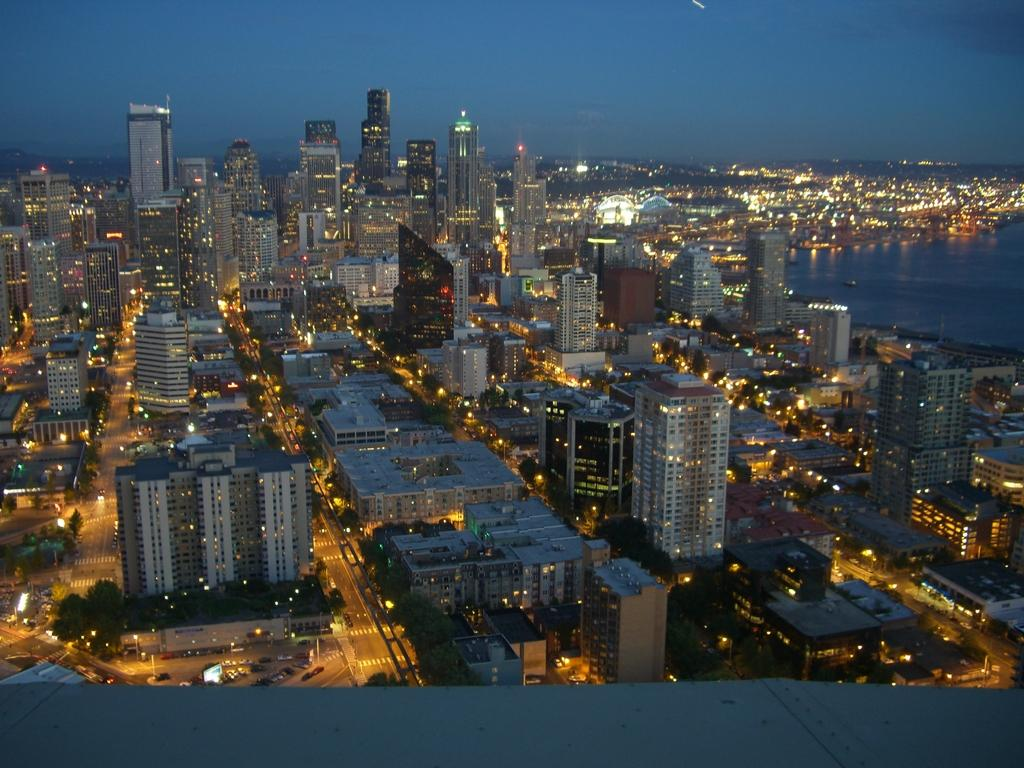What type of structures can be seen in the image? There are buildings with lights in the image. What can be found between the buildings? There are roads in the image. What else is present in the image besides buildings and roads? There are trees in the image. What is moving along the roads? There are vehicles on the roads. What can be seen in the background of the image? In the background, there are clouds in the blue sky. Can you tell me how many books are on the road in the image? There are no books present in the image; it features buildings, roads, trees, vehicles, water, and a blue sky with clouds. What type of tool is being used to fix the wrench in the image? There is no wrench present in the image. 